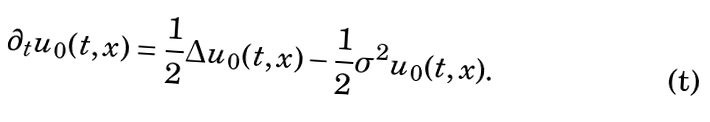<formula> <loc_0><loc_0><loc_500><loc_500>\partial _ { t } u _ { 0 } ( t , x ) = \frac { 1 } { 2 } \Delta u _ { 0 } ( t , x ) - \frac { 1 } { 2 } \sigma ^ { 2 } u _ { 0 } ( t , x ) .</formula> 